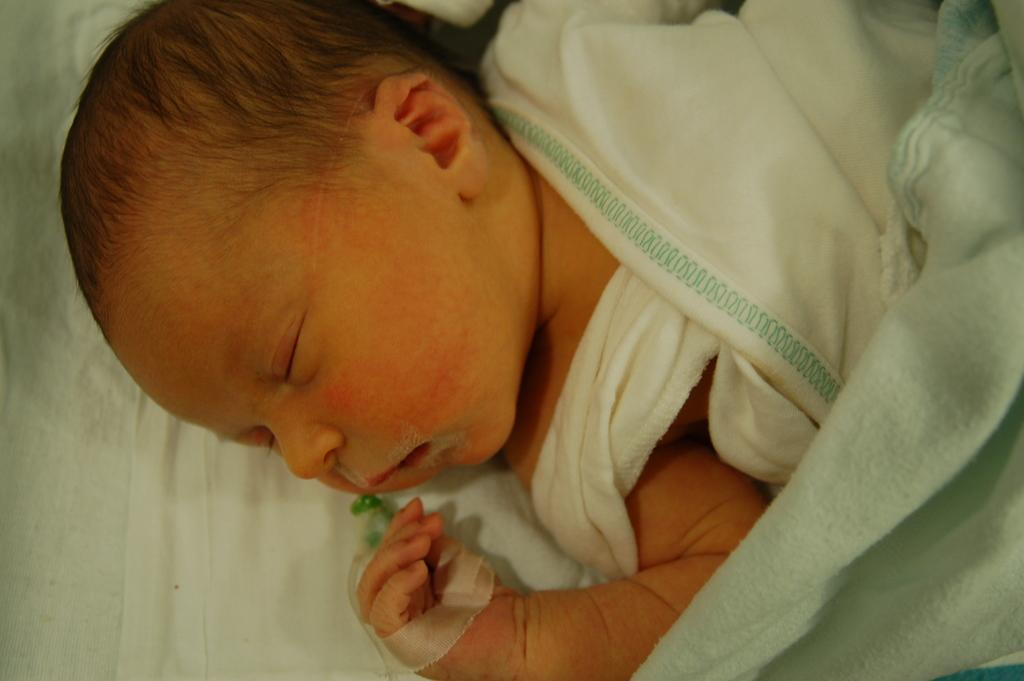What is the main subject of the image? There is a baby in the image. What is the baby doing in the image? The baby is sleeping. What can be seen covering the baby in the image? There is a white color blanket in the image. What scene is the baby joining in the image? There is no scene or event in the image that the baby is joining; the baby is simply sleeping. How many stars can be seen in the image? There are no stars visible in the image. 